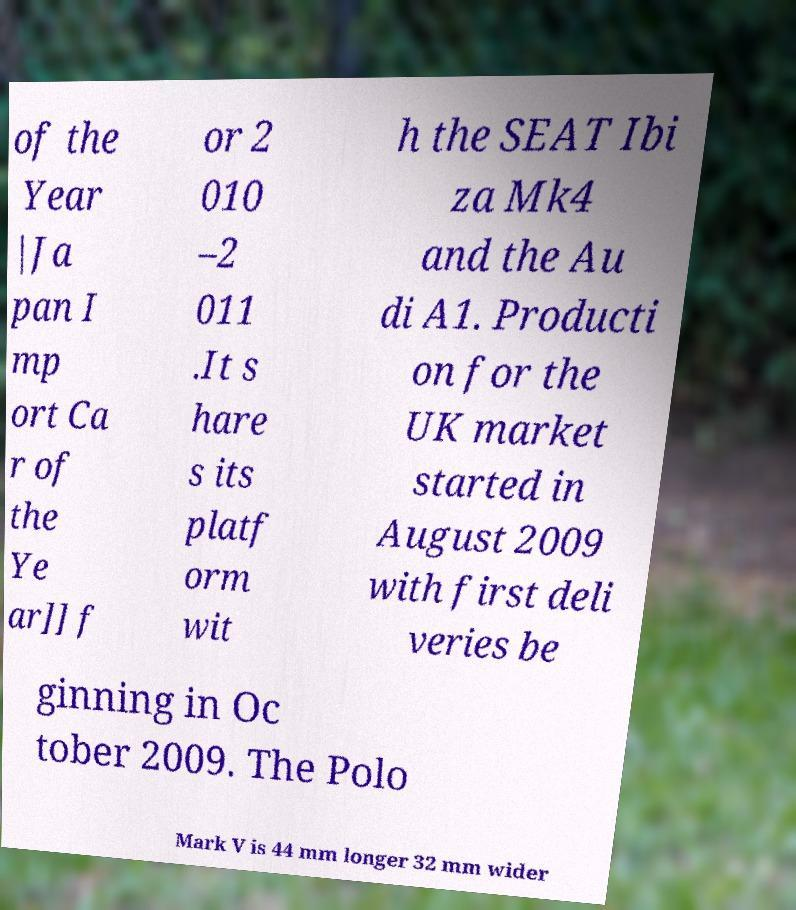Can you read and provide the text displayed in the image?This photo seems to have some interesting text. Can you extract and type it out for me? of the Year |Ja pan I mp ort Ca r of the Ye ar]] f or 2 010 –2 011 .It s hare s its platf orm wit h the SEAT Ibi za Mk4 and the Au di A1. Producti on for the UK market started in August 2009 with first deli veries be ginning in Oc tober 2009. The Polo Mark V is 44 mm longer 32 mm wider 